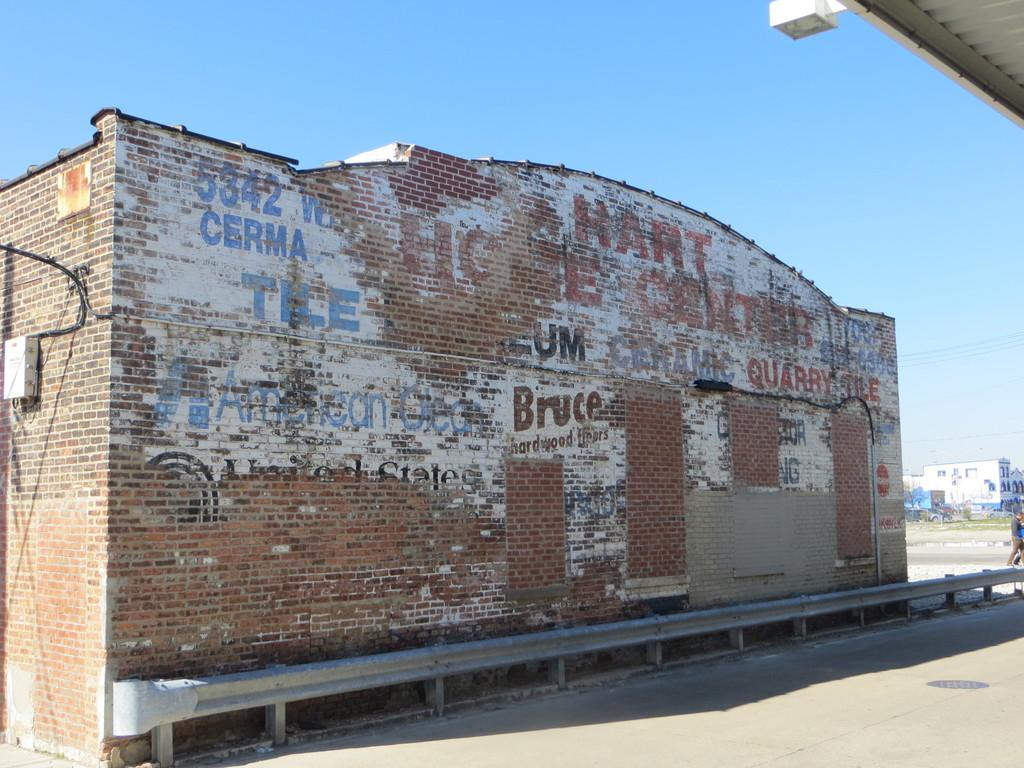What type of house is in the image? There is a brick house in the image. What can be seen on the house? There is text visible on the house. What is in the foreground of the image? There is a road in the image. Who or what can be seen in the image? There are people visible in the image. What else can be seen in the image besides the house? There are buildings and wires present in the image. What is the color of the sky in the background of the image? The sky is blue in the background of the image. Where are the ants located in the image? There are no ants present in the image. What type of bells can be heard ringing in the image? There are no bells present in the image, and therefore no sound can be heard. 